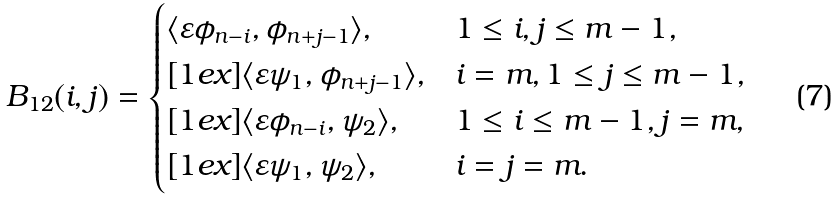Convert formula to latex. <formula><loc_0><loc_0><loc_500><loc_500>B _ { 1 2 } ( i , j ) = \begin{cases} \langle \varepsilon \phi _ { n - i } , \phi _ { n + j - 1 } \rangle , & 1 \leq i , j \leq m - 1 , \\ [ 1 e x ] \langle \varepsilon \psi _ { 1 } , \phi _ { n + j - 1 } \rangle , & i = m , 1 \leq j \leq m - 1 , \\ [ 1 e x ] \langle \varepsilon \phi _ { n - i } , \psi _ { 2 } \rangle , & 1 \leq i \leq m - 1 , j = m , \\ [ 1 e x ] \langle \varepsilon \psi _ { 1 } , \psi _ { 2 } \rangle , & i = j = m . \end{cases}</formula> 